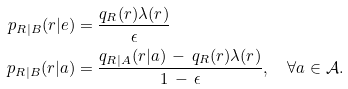Convert formula to latex. <formula><loc_0><loc_0><loc_500><loc_500>p _ { R | B } ( r | e ) & = \frac { q _ { R } ( r ) \lambda ( r ) } { \epsilon } \\ p _ { R | B } ( r | a ) & = \frac { q _ { R | A } ( r | a ) \, - \, q _ { R } ( r ) \lambda ( r ) } { 1 \, - \, \epsilon } , \quad \forall a \in \mathcal { A } .</formula> 